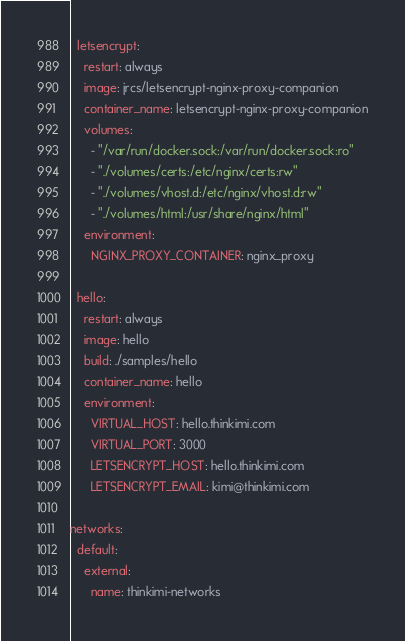<code> <loc_0><loc_0><loc_500><loc_500><_YAML_>  letsencrypt:
    restart: always
    image: jrcs/letsencrypt-nginx-proxy-companion
    container_name: letsencrypt-nginx-proxy-companion
    volumes:
      - "/var/run/docker.sock:/var/run/docker.sock:ro"
      - "./volumes/certs:/etc/nginx/certs:rw"
      - "./volumes/vhost.d:/etc/nginx/vhost.d:rw"
      - "./volumes/html:/usr/share/nginx/html"
    environment:
      NGINX_PROXY_CONTAINER: nginx_proxy

  hello:
    restart: always
    image: hello
    build: ./samples/hello
    container_name: hello
    environment:
      VIRTUAL_HOST: hello.thinkimi.com
      VIRTUAL_PORT: 3000
      LETSENCRYPT_HOST: hello.thinkimi.com
      LETSENCRYPT_EMAIL: kimi@thinkimi.com

networks:
  default:
    external:
      name: thinkimi-networks
</code> 